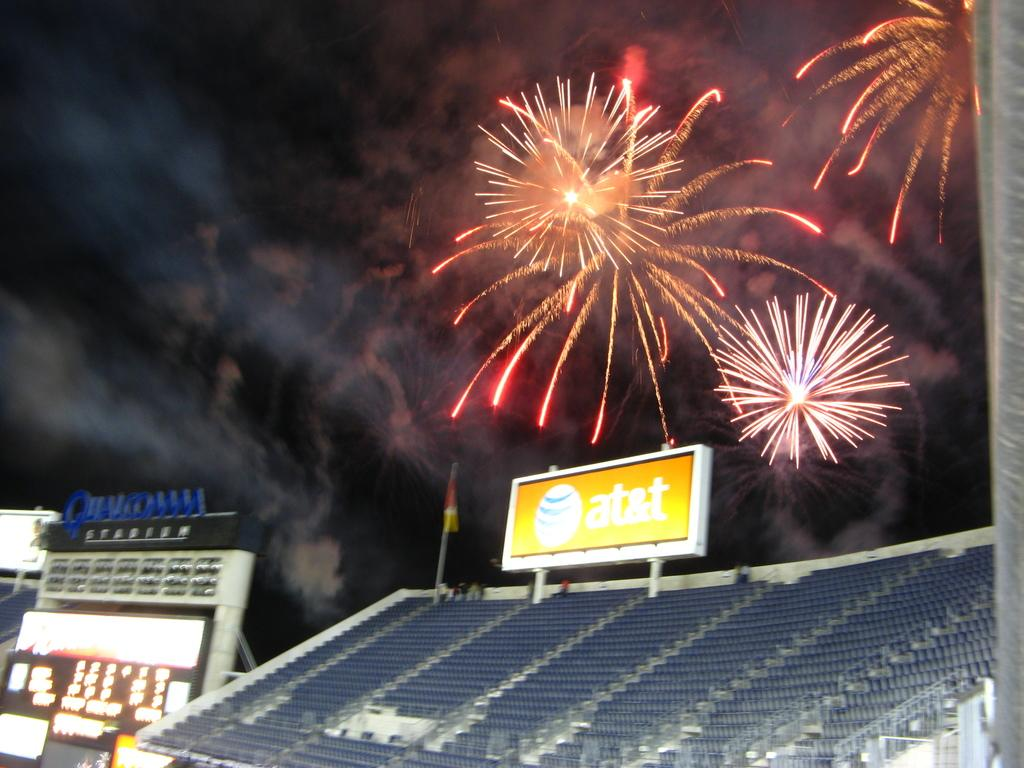<image>
Summarize the visual content of the image. Fireworks going off above a billboard for AT&T. 